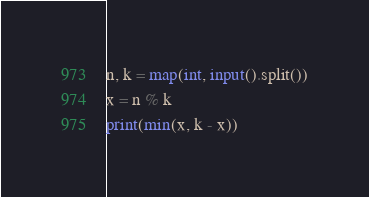Convert code to text. <code><loc_0><loc_0><loc_500><loc_500><_Python_>n, k = map(int, input().split())
x = n % k
print(min(x, k - x))</code> 